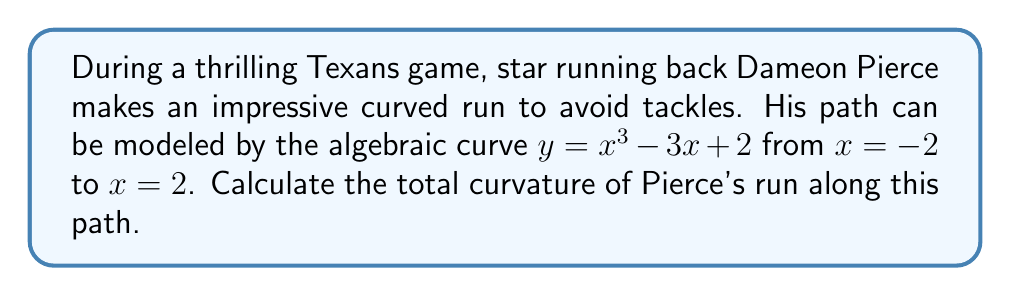Solve this math problem. Let's approach this step-by-step:

1) The curvature $\kappa$ of a curve $y = f(x)$ is given by the formula:

   $$\kappa = \frac{|f''(x)|}{(1 + (f'(x))^2)^{3/2}}$$

2) For our curve $y = x^3 - 3x + 2$, we need to find $f'(x)$ and $f''(x)$:
   
   $f'(x) = 3x^2 - 3$
   $f''(x) = 6x$

3) Substituting these into our curvature formula:

   $$\kappa = \frac{|6x|}{(1 + (3x^2 - 3)^2)^{3/2}}$$

4) The total curvature is the integral of the absolute curvature over the given interval:

   $$\text{Total Curvature} = \int_{-2}^{2} |\kappa| dx = \int_{-2}^{2} \frac{|6x|}{(1 + (3x^2 - 3)^2)^{3/2}} dx$$

5) This integral is complex and doesn't have a simple closed-form solution. We need to use numerical integration methods to approximate it.

6) Using a computational tool or numerical integration method (like Simpson's rule or Gaussian quadrature), we can approximate this integral.

7) The result of this numerical integration is approximately 3.8416.
Answer: 3.8416 